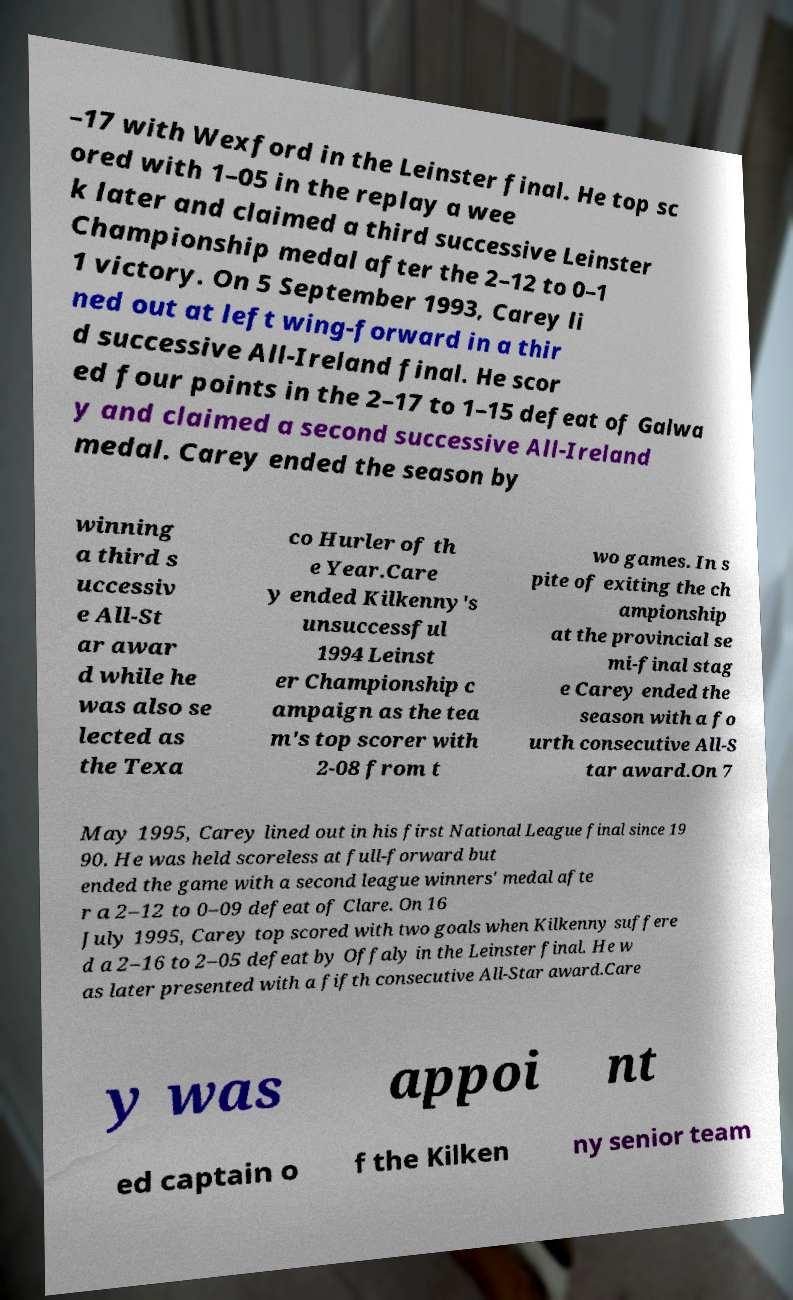I need the written content from this picture converted into text. Can you do that? –17 with Wexford in the Leinster final. He top sc ored with 1–05 in the replay a wee k later and claimed a third successive Leinster Championship medal after the 2–12 to 0–1 1 victory. On 5 September 1993, Carey li ned out at left wing-forward in a thir d successive All-Ireland final. He scor ed four points in the 2–17 to 1–15 defeat of Galwa y and claimed a second successive All-Ireland medal. Carey ended the season by winning a third s uccessiv e All-St ar awar d while he was also se lected as the Texa co Hurler of th e Year.Care y ended Kilkenny's unsuccessful 1994 Leinst er Championship c ampaign as the tea m's top scorer with 2-08 from t wo games. In s pite of exiting the ch ampionship at the provincial se mi-final stag e Carey ended the season with a fo urth consecutive All-S tar award.On 7 May 1995, Carey lined out in his first National League final since 19 90. He was held scoreless at full-forward but ended the game with a second league winners' medal afte r a 2–12 to 0–09 defeat of Clare. On 16 July 1995, Carey top scored with two goals when Kilkenny suffere d a 2–16 to 2–05 defeat by Offaly in the Leinster final. He w as later presented with a fifth consecutive All-Star award.Care y was appoi nt ed captain o f the Kilken ny senior team 